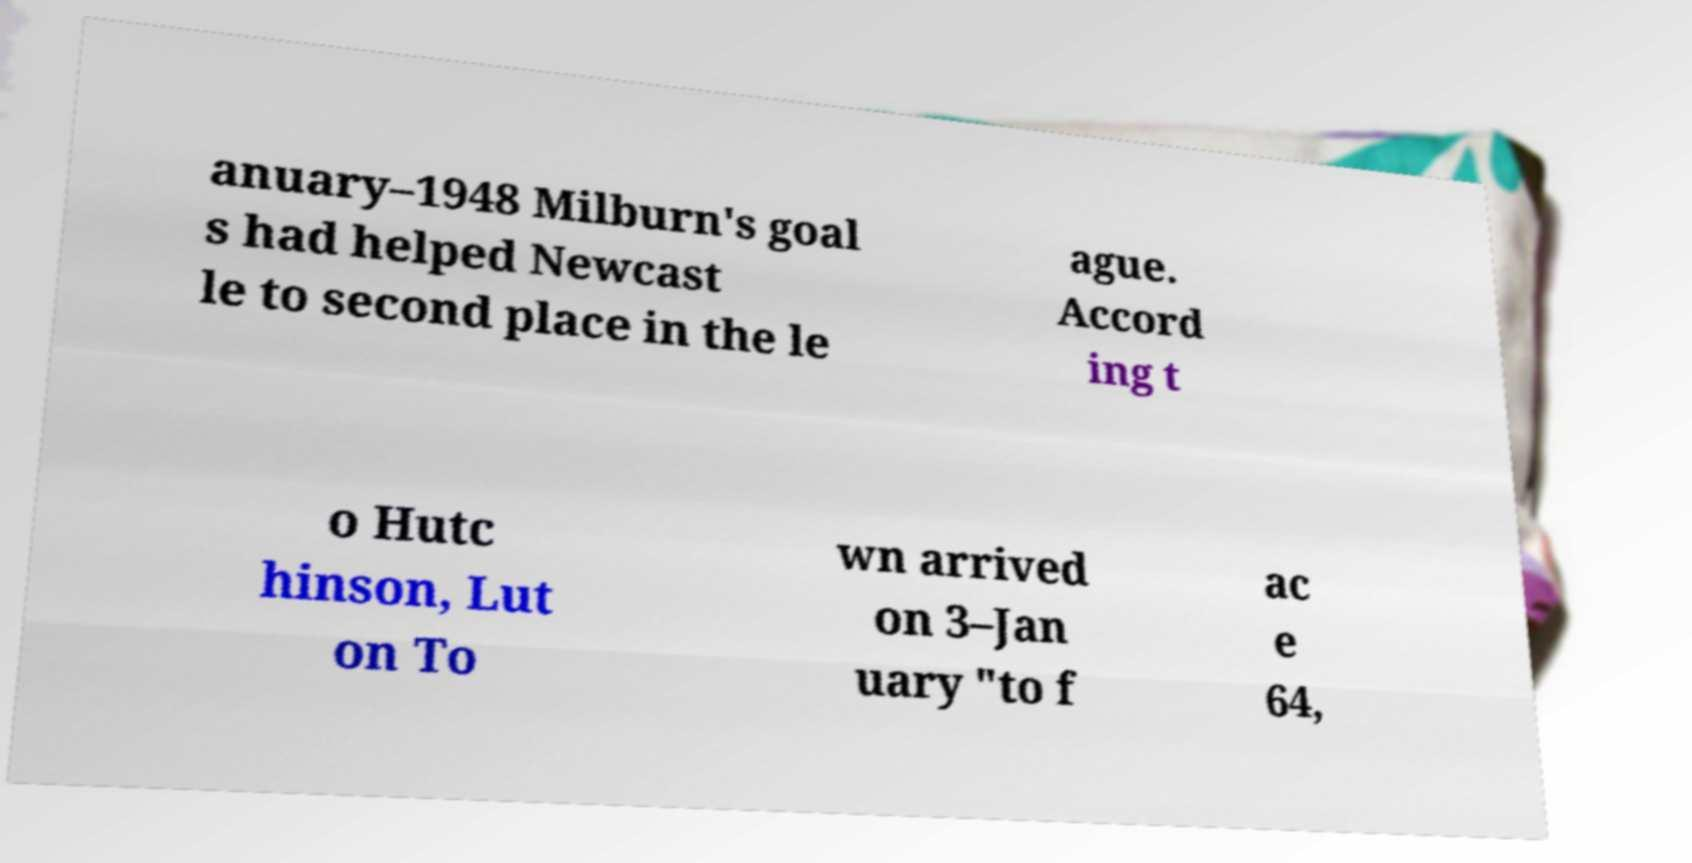Could you assist in decoding the text presented in this image and type it out clearly? anuary–1948 Milburn's goal s had helped Newcast le to second place in the le ague. Accord ing t o Hutc hinson, Lut on To wn arrived on 3–Jan uary "to f ac e 64, 